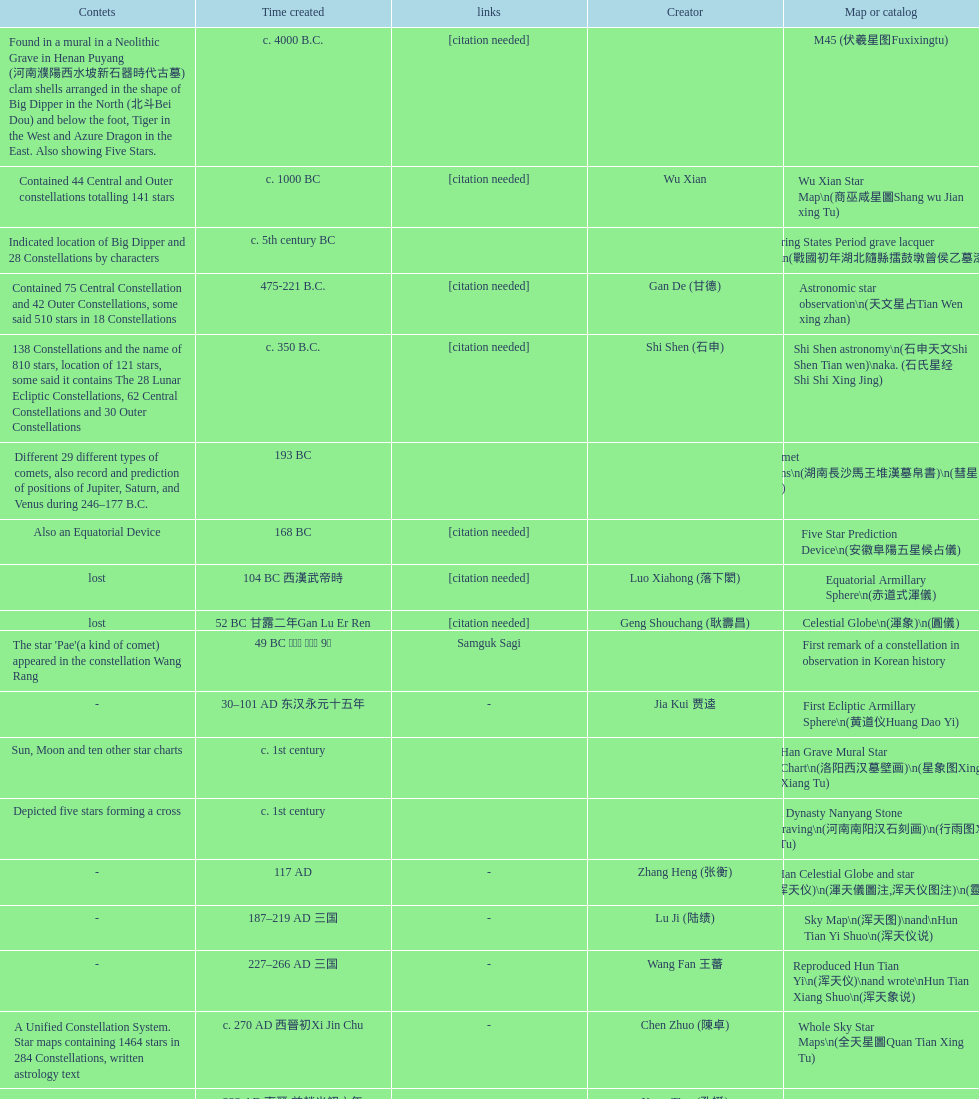What is the difference between the five star prediction device's date of creation and the han comet diagrams' date of creation? 25 years. 